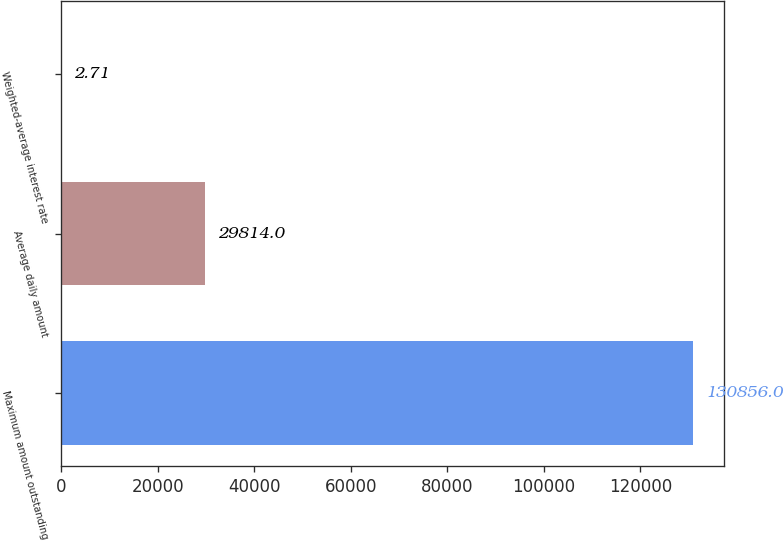Convert chart to OTSL. <chart><loc_0><loc_0><loc_500><loc_500><bar_chart><fcel>Maximum amount outstanding<fcel>Average daily amount<fcel>Weighted-average interest rate<nl><fcel>130856<fcel>29814<fcel>2.71<nl></chart> 